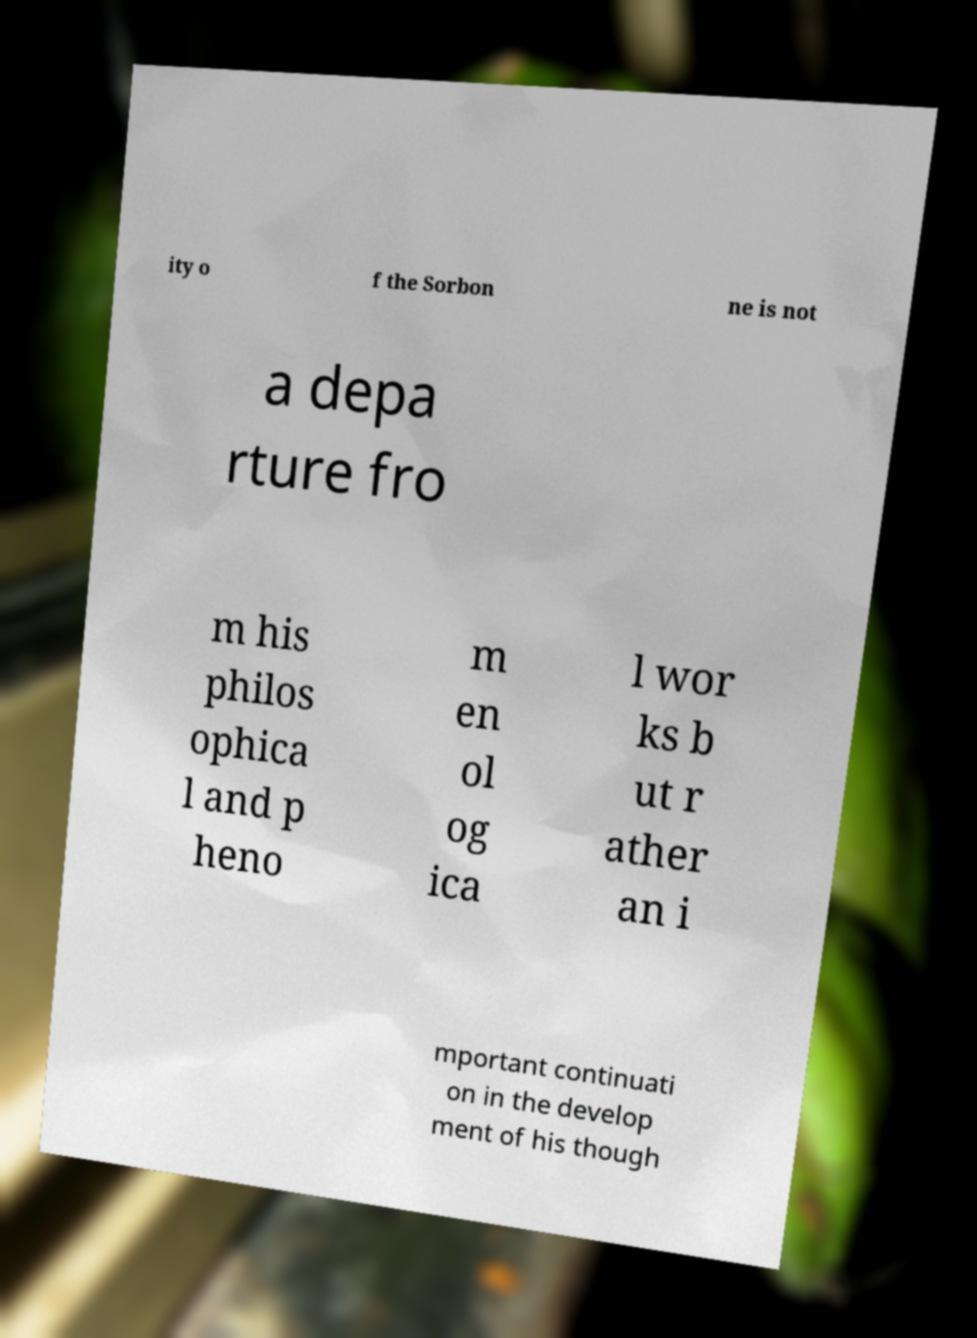For documentation purposes, I need the text within this image transcribed. Could you provide that? ity o f the Sorbon ne is not a depa rture fro m his philos ophica l and p heno m en ol og ica l wor ks b ut r ather an i mportant continuati on in the develop ment of his though 